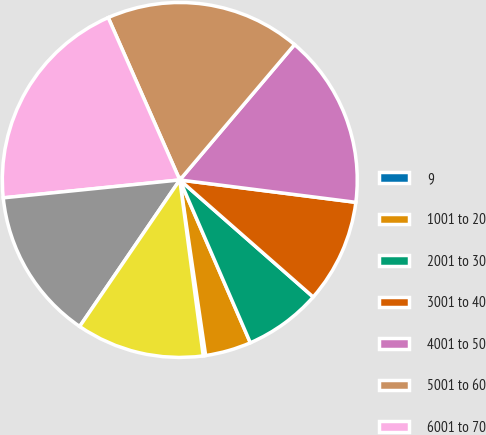<chart> <loc_0><loc_0><loc_500><loc_500><pie_chart><fcel>9<fcel>1001 to 20<fcel>2001 to 30<fcel>3001 to 40<fcel>4001 to 50<fcel>5001 to 60<fcel>6001 to 70<fcel>Options Outstanding<fcel>Options Exercisable<nl><fcel>0.22%<fcel>4.18%<fcel>7.03%<fcel>9.45%<fcel>15.82%<fcel>17.8%<fcel>20.0%<fcel>13.85%<fcel>11.65%<nl></chart> 